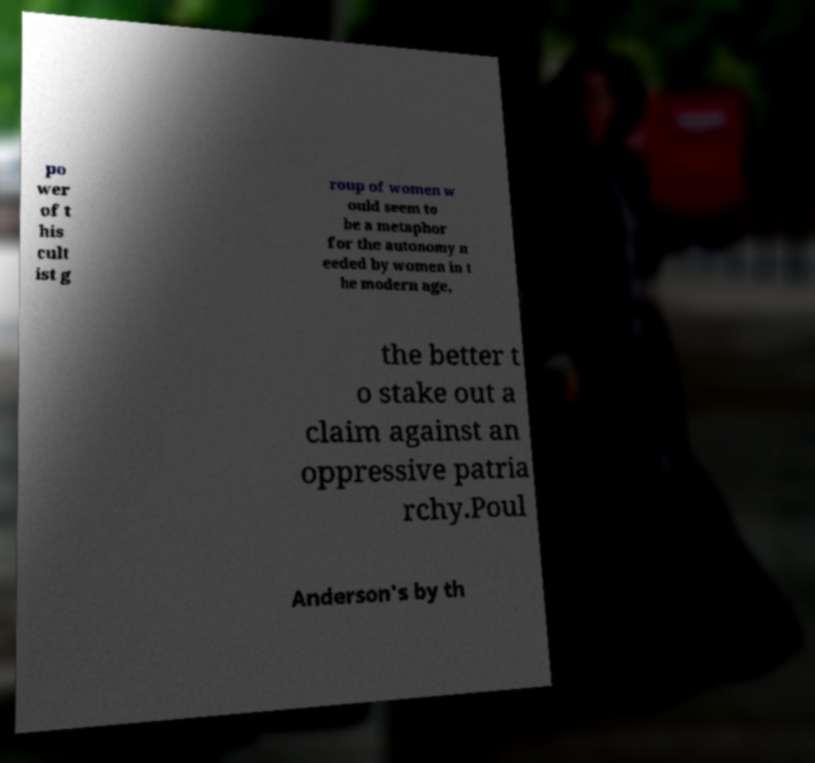Can you accurately transcribe the text from the provided image for me? po wer of t his cult ist g roup of women w ould seem to be a metaphor for the autonomy n eeded by women in t he modern age, the better t o stake out a claim against an oppressive patria rchy.Poul Anderson's by th 